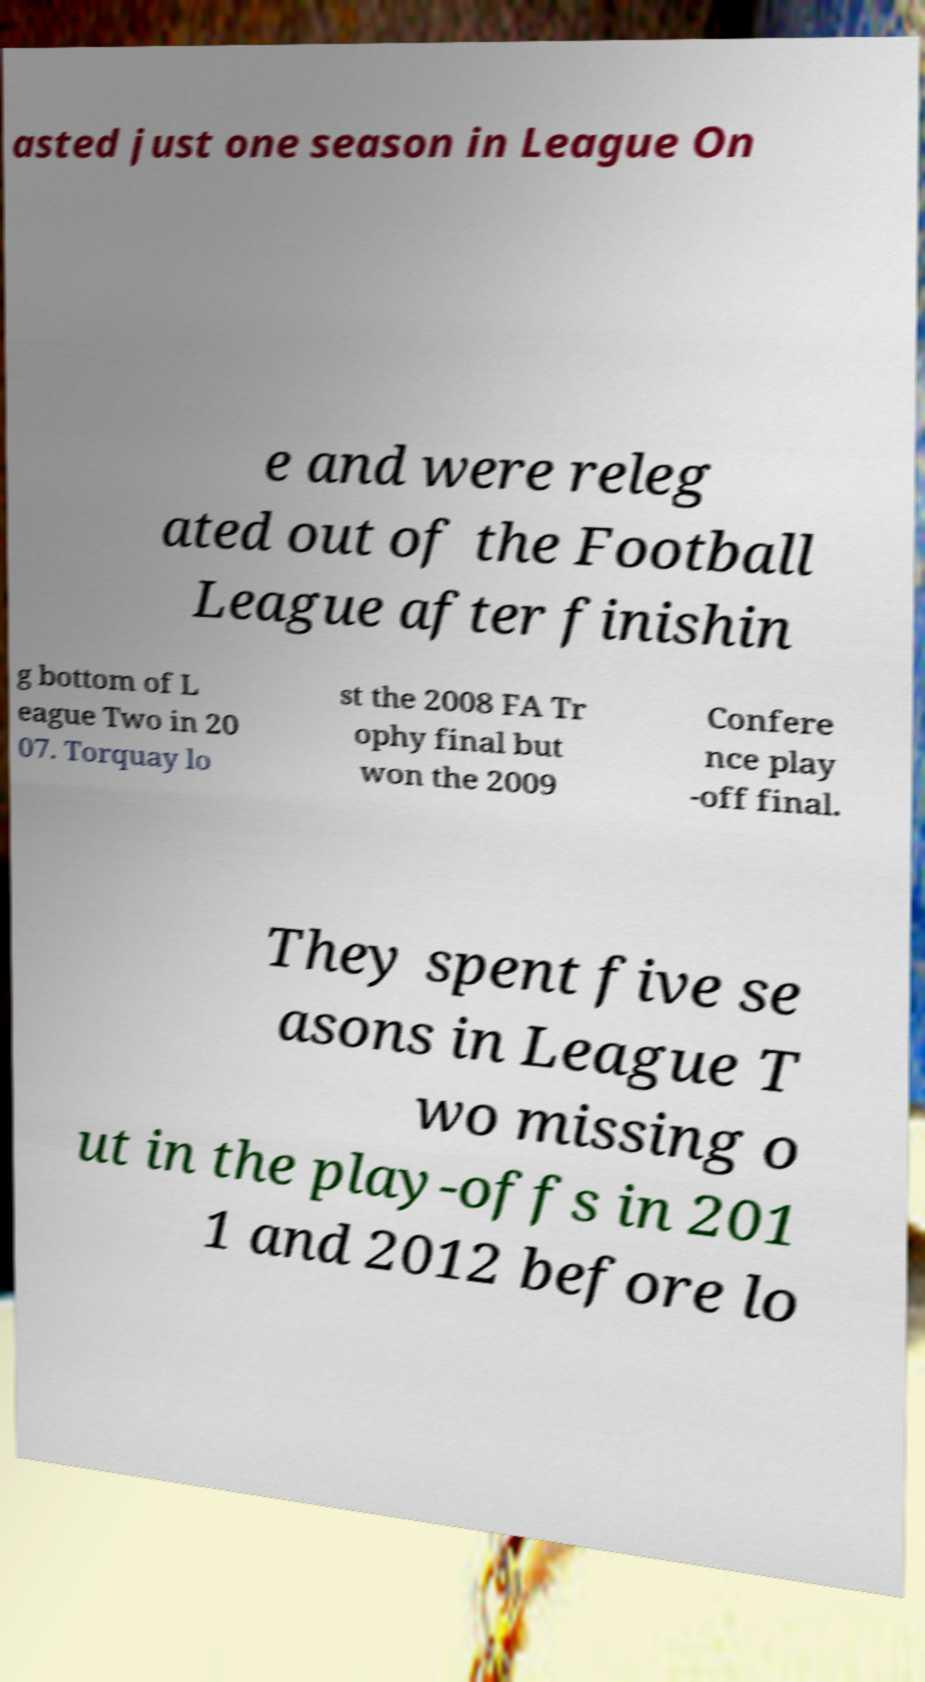Can you read and provide the text displayed in the image?This photo seems to have some interesting text. Can you extract and type it out for me? asted just one season in League On e and were releg ated out of the Football League after finishin g bottom of L eague Two in 20 07. Torquay lo st the 2008 FA Tr ophy final but won the 2009 Confere nce play -off final. They spent five se asons in League T wo missing o ut in the play-offs in 201 1 and 2012 before lo 